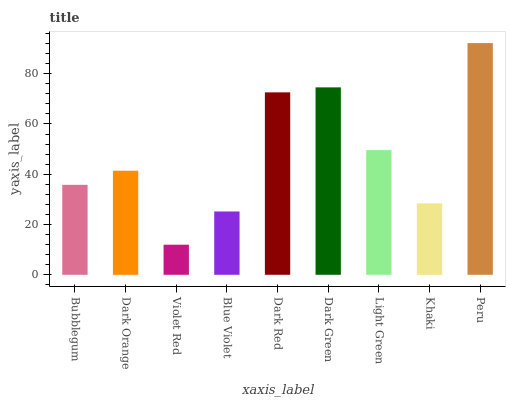Is Dark Orange the minimum?
Answer yes or no. No. Is Dark Orange the maximum?
Answer yes or no. No. Is Dark Orange greater than Bubblegum?
Answer yes or no. Yes. Is Bubblegum less than Dark Orange?
Answer yes or no. Yes. Is Bubblegum greater than Dark Orange?
Answer yes or no. No. Is Dark Orange less than Bubblegum?
Answer yes or no. No. Is Dark Orange the high median?
Answer yes or no. Yes. Is Dark Orange the low median?
Answer yes or no. Yes. Is Blue Violet the high median?
Answer yes or no. No. Is Peru the low median?
Answer yes or no. No. 